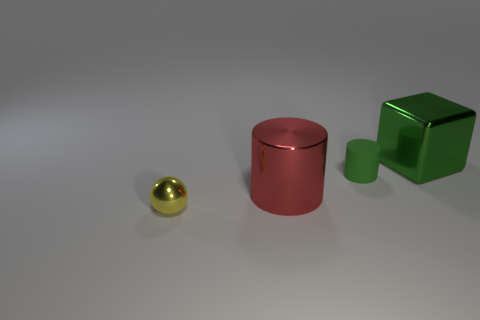What number of other objects are there of the same material as the tiny green object? 0 